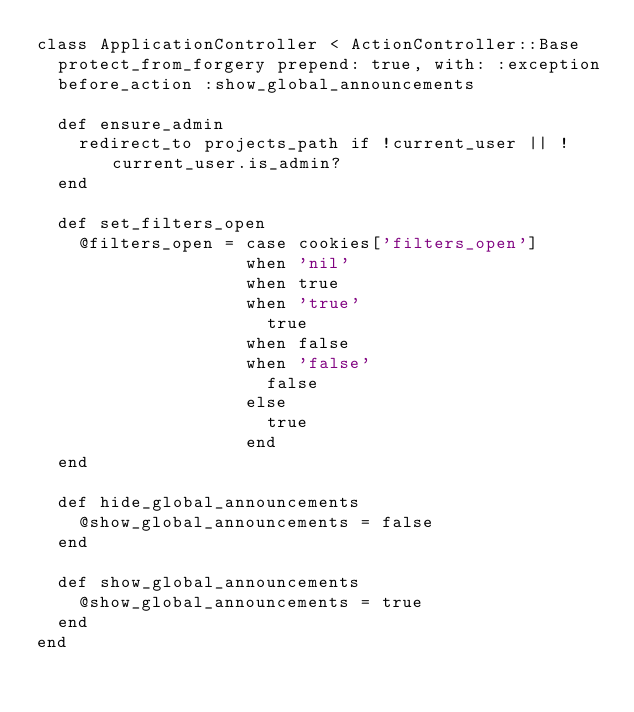Convert code to text. <code><loc_0><loc_0><loc_500><loc_500><_Ruby_>class ApplicationController < ActionController::Base
  protect_from_forgery prepend: true, with: :exception
  before_action :show_global_announcements

  def ensure_admin
    redirect_to projects_path if !current_user || !current_user.is_admin?
  end

  def set_filters_open
    @filters_open = case cookies['filters_open']
                    when 'nil'
                    when true
                    when 'true'
                      true
                    when false
                    when 'false'
                      false
                    else
                      true
                    end
  end

  def hide_global_announcements
    @show_global_announcements = false
  end

  def show_global_announcements
    @show_global_announcements = true
  end
end
</code> 